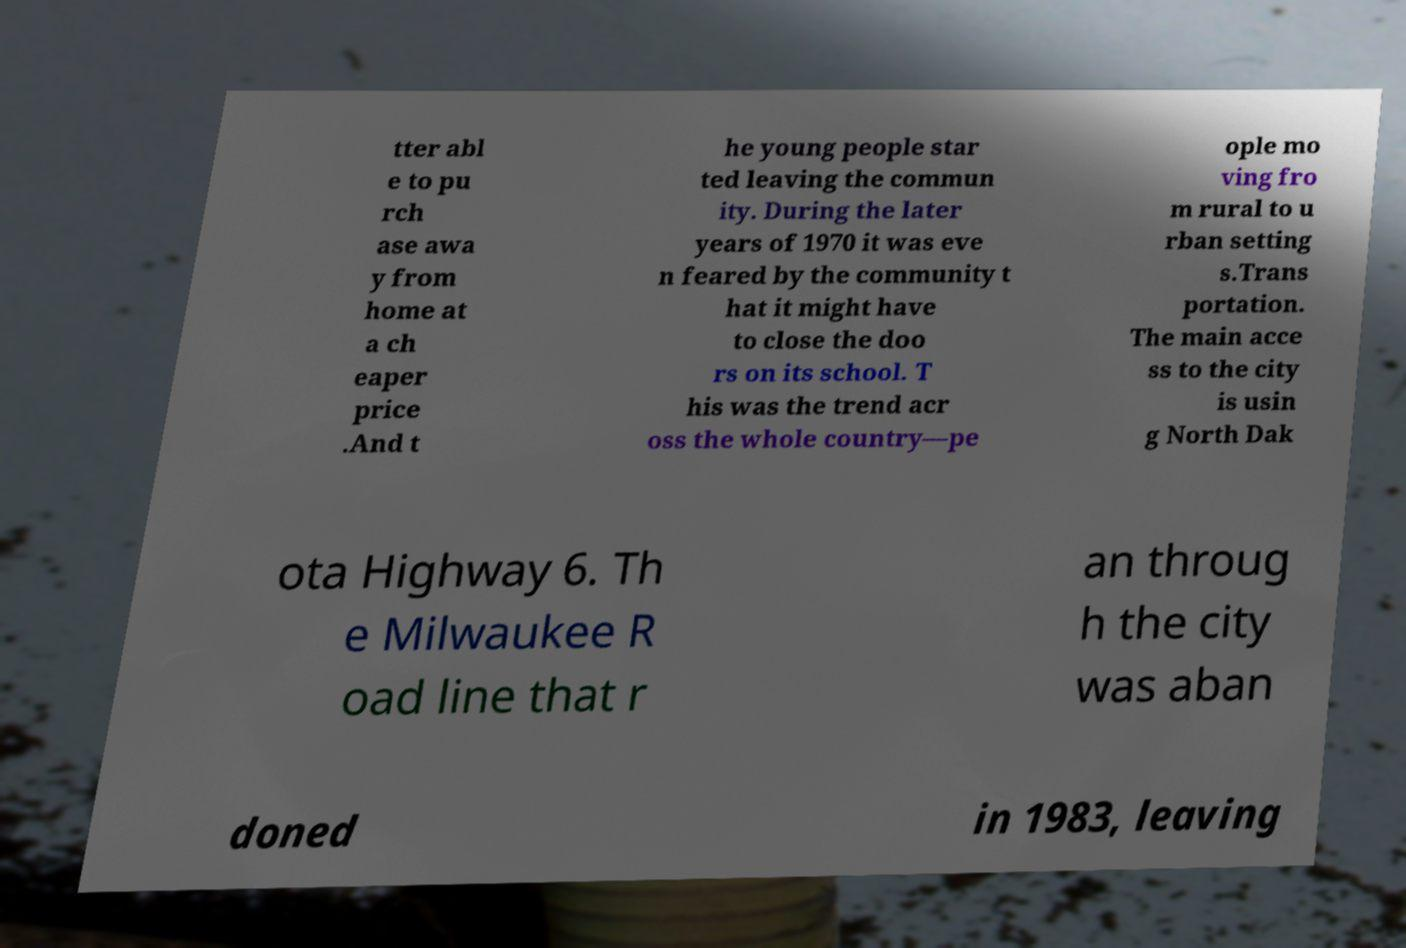Could you assist in decoding the text presented in this image and type it out clearly? tter abl e to pu rch ase awa y from home at a ch eaper price .And t he young people star ted leaving the commun ity. During the later years of 1970 it was eve n feared by the community t hat it might have to close the doo rs on its school. T his was the trend acr oss the whole country—pe ople mo ving fro m rural to u rban setting s.Trans portation. The main acce ss to the city is usin g North Dak ota Highway 6. Th e Milwaukee R oad line that r an throug h the city was aban doned in 1983, leaving 